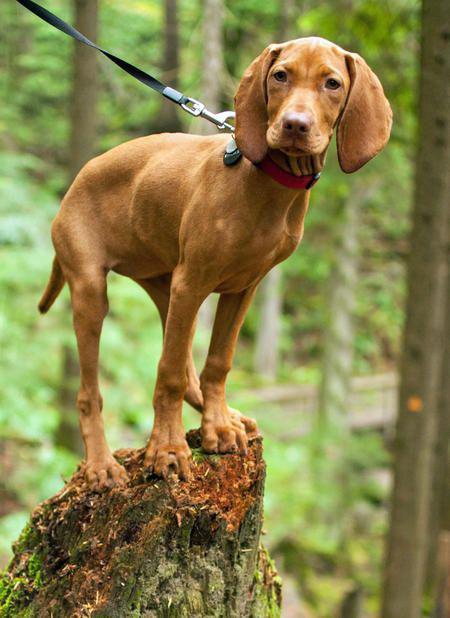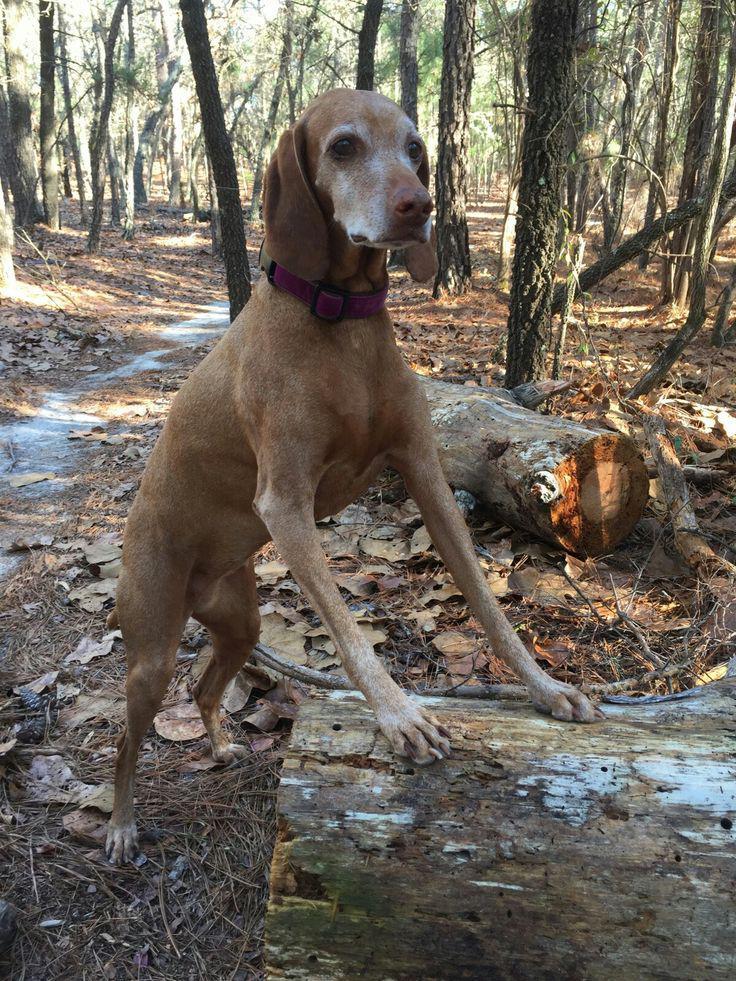The first image is the image on the left, the second image is the image on the right. Considering the images on both sides, is "There is three dogs." valid? Answer yes or no. No. The first image is the image on the left, the second image is the image on the right. Considering the images on both sides, is "In one image, a red-orange dog in a collar with a leash attached stands on a high rock perch gazing." valid? Answer yes or no. Yes. 